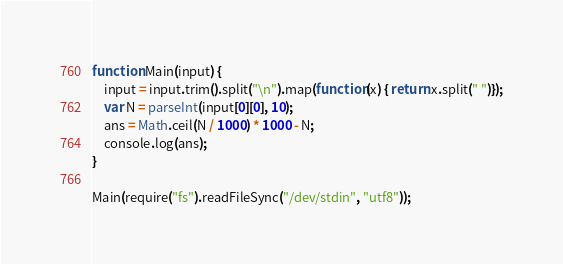Convert code to text. <code><loc_0><loc_0><loc_500><loc_500><_JavaScript_>function Main(input) {
    input = input.trim().split("\n").map(function(x) { return x.split(" ")});
    var N = parseInt(input[0][0], 10);
    ans = Math.ceil(N / 1000) * 1000 - N;
    console.log(ans);
}

Main(require("fs").readFileSync("/dev/stdin", "utf8")); </code> 